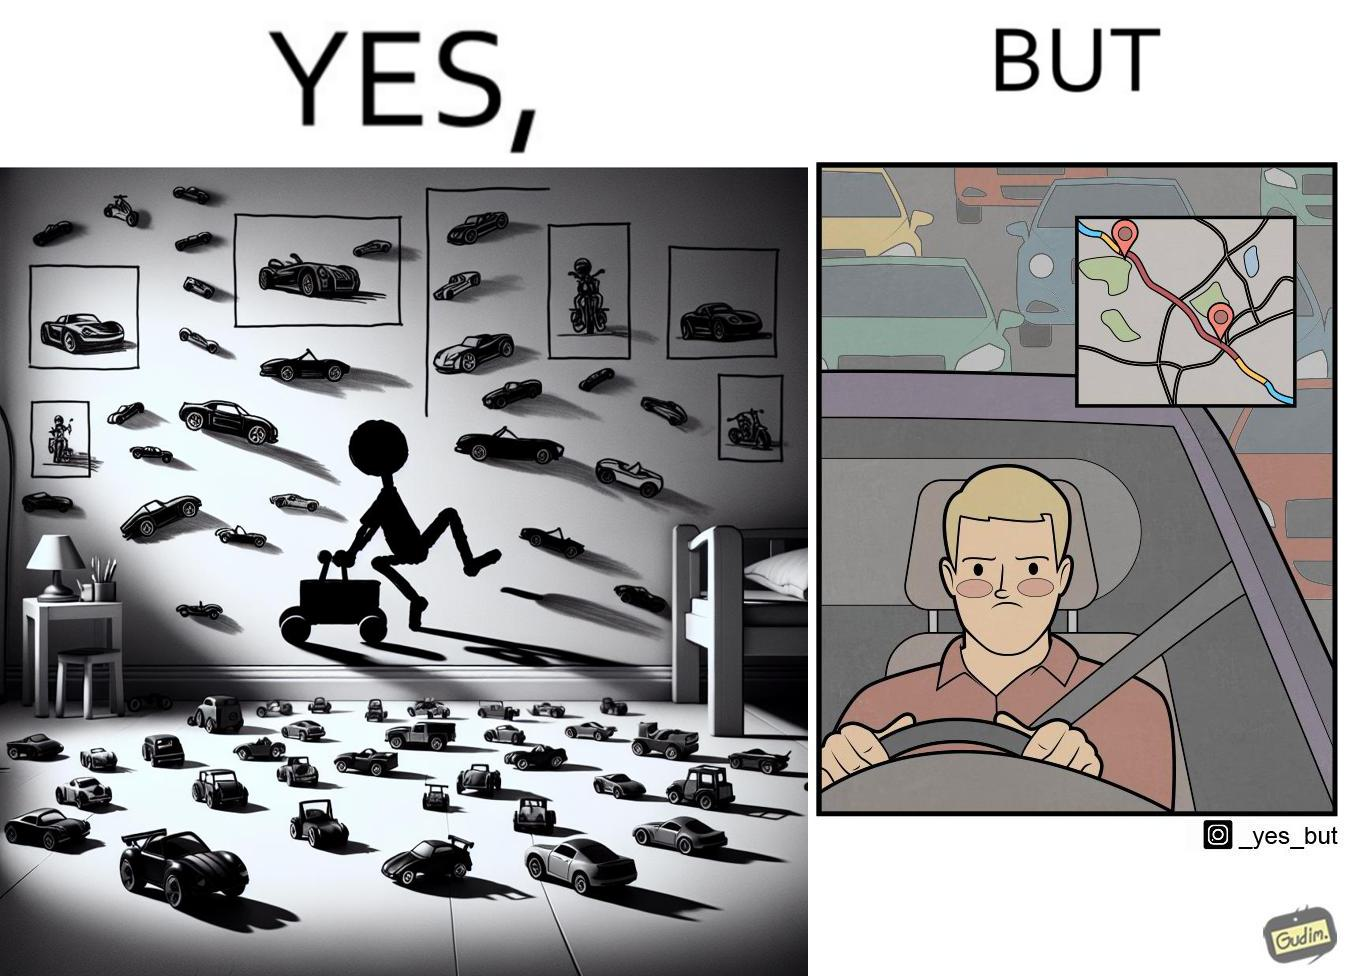What is shown in this image? The image is funny beaucse while the person as a child enjoyed being around cars, had various small toy cars and even rode a bigger toy car, as as grown up he does not enjoy being in a car during a traffic jam while he is driving . 